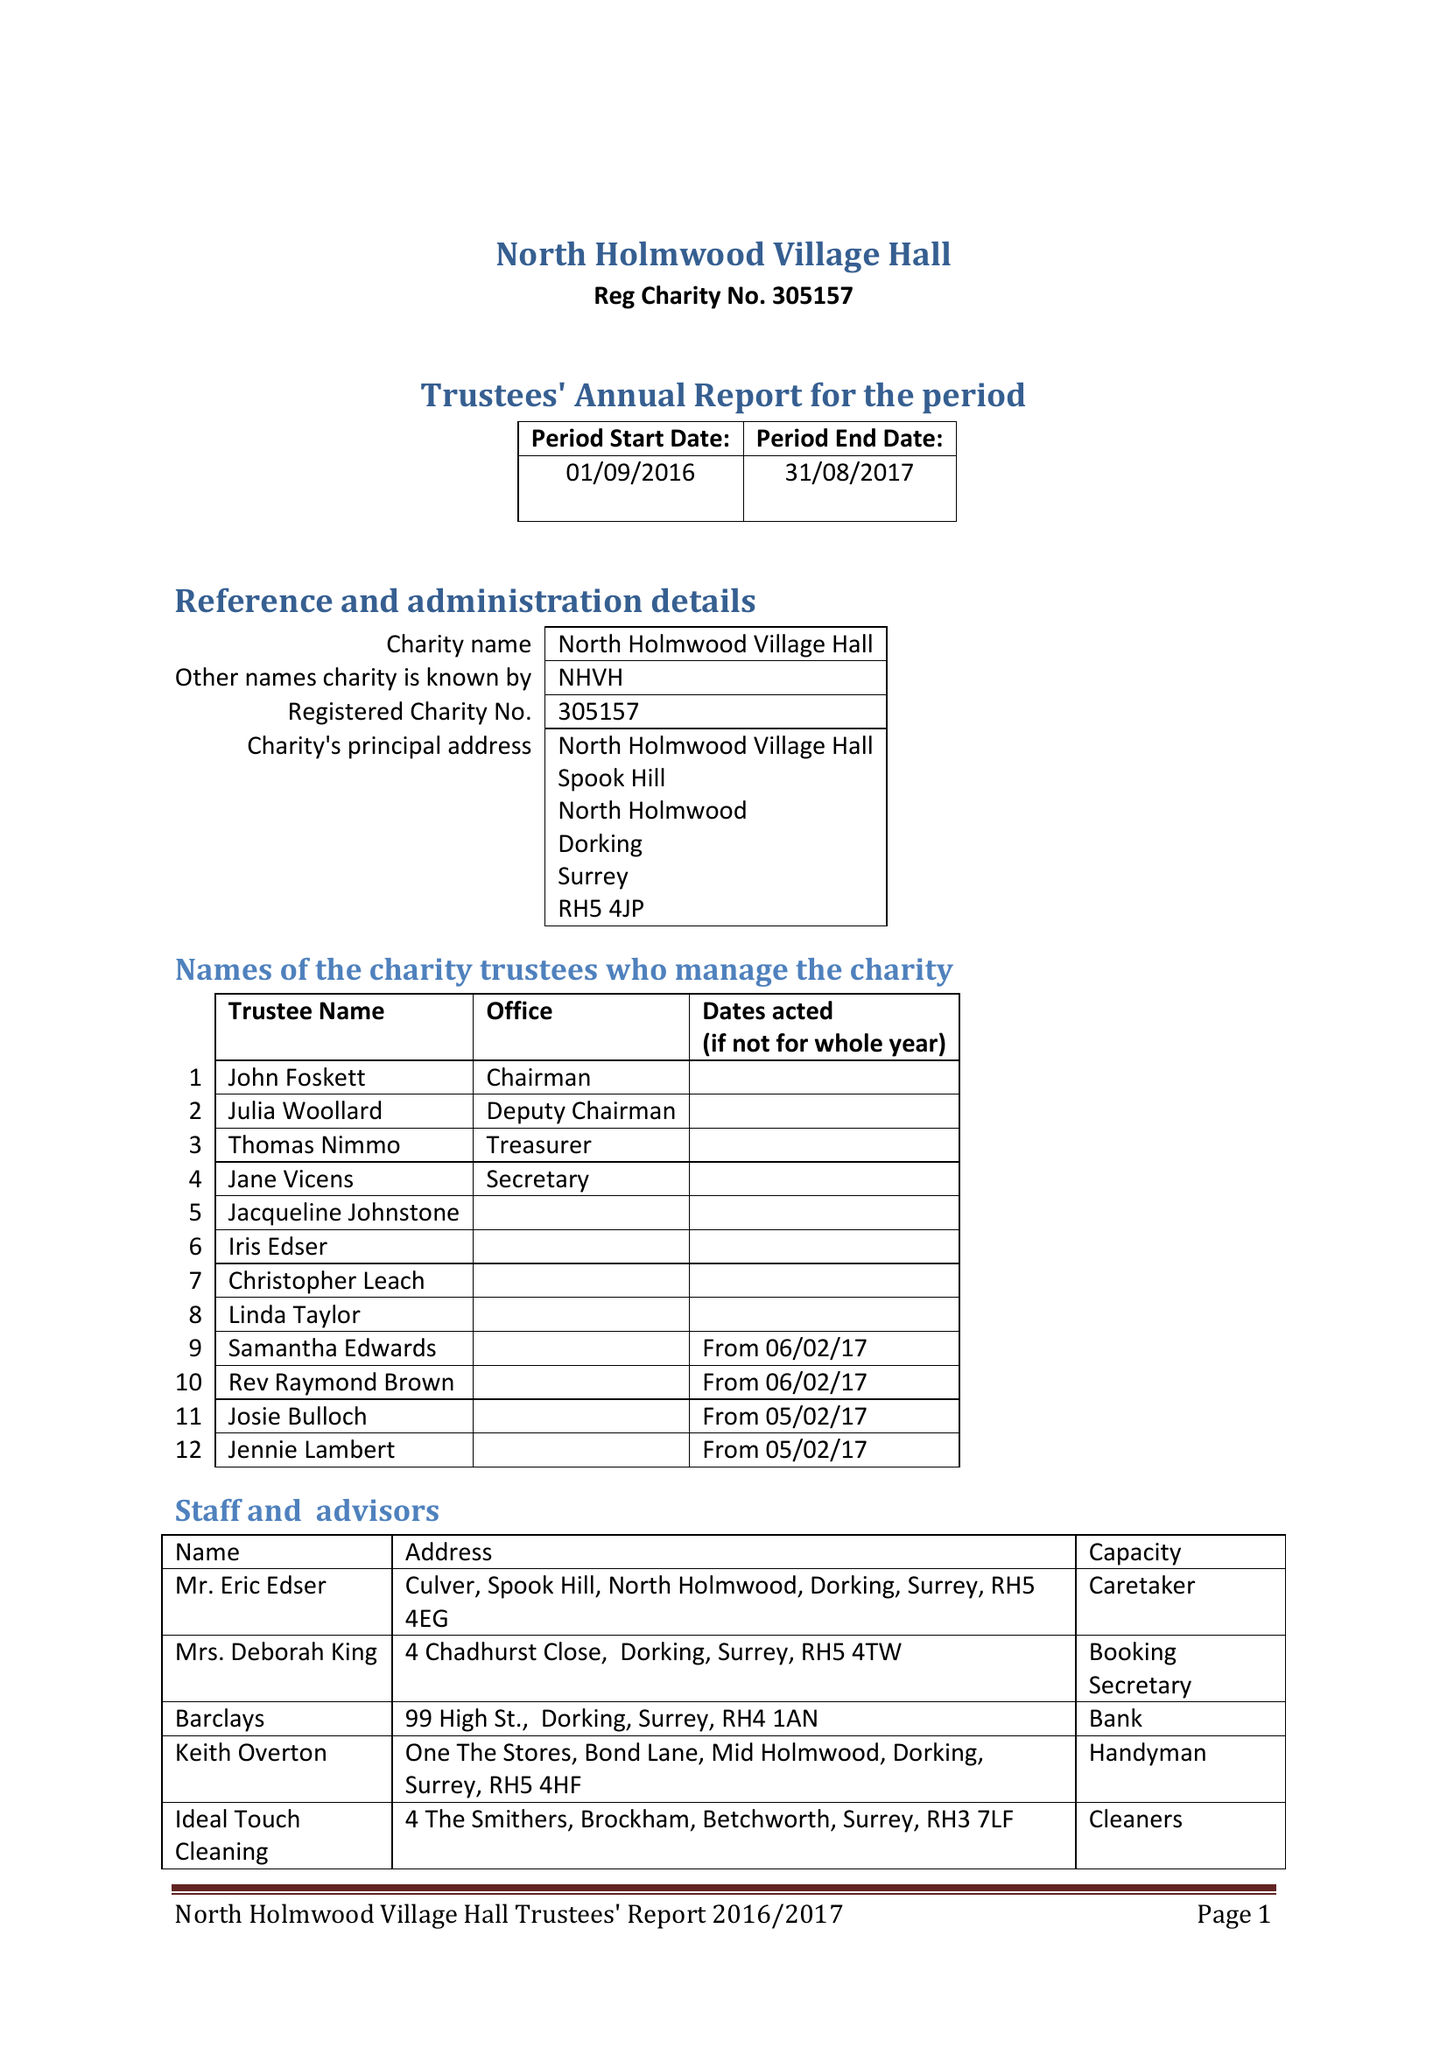What is the value for the charity_name?
Answer the question using a single word or phrase. North Holmwood Village Hall 